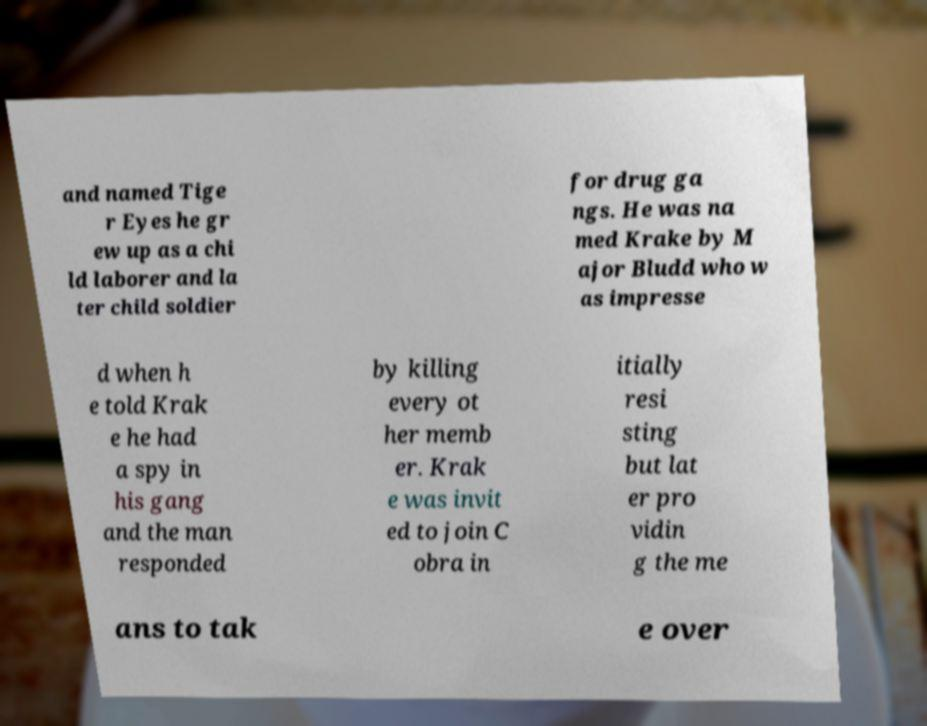Could you extract and type out the text from this image? and named Tige r Eyes he gr ew up as a chi ld laborer and la ter child soldier for drug ga ngs. He was na med Krake by M ajor Bludd who w as impresse d when h e told Krak e he had a spy in his gang and the man responded by killing every ot her memb er. Krak e was invit ed to join C obra in itially resi sting but lat er pro vidin g the me ans to tak e over 